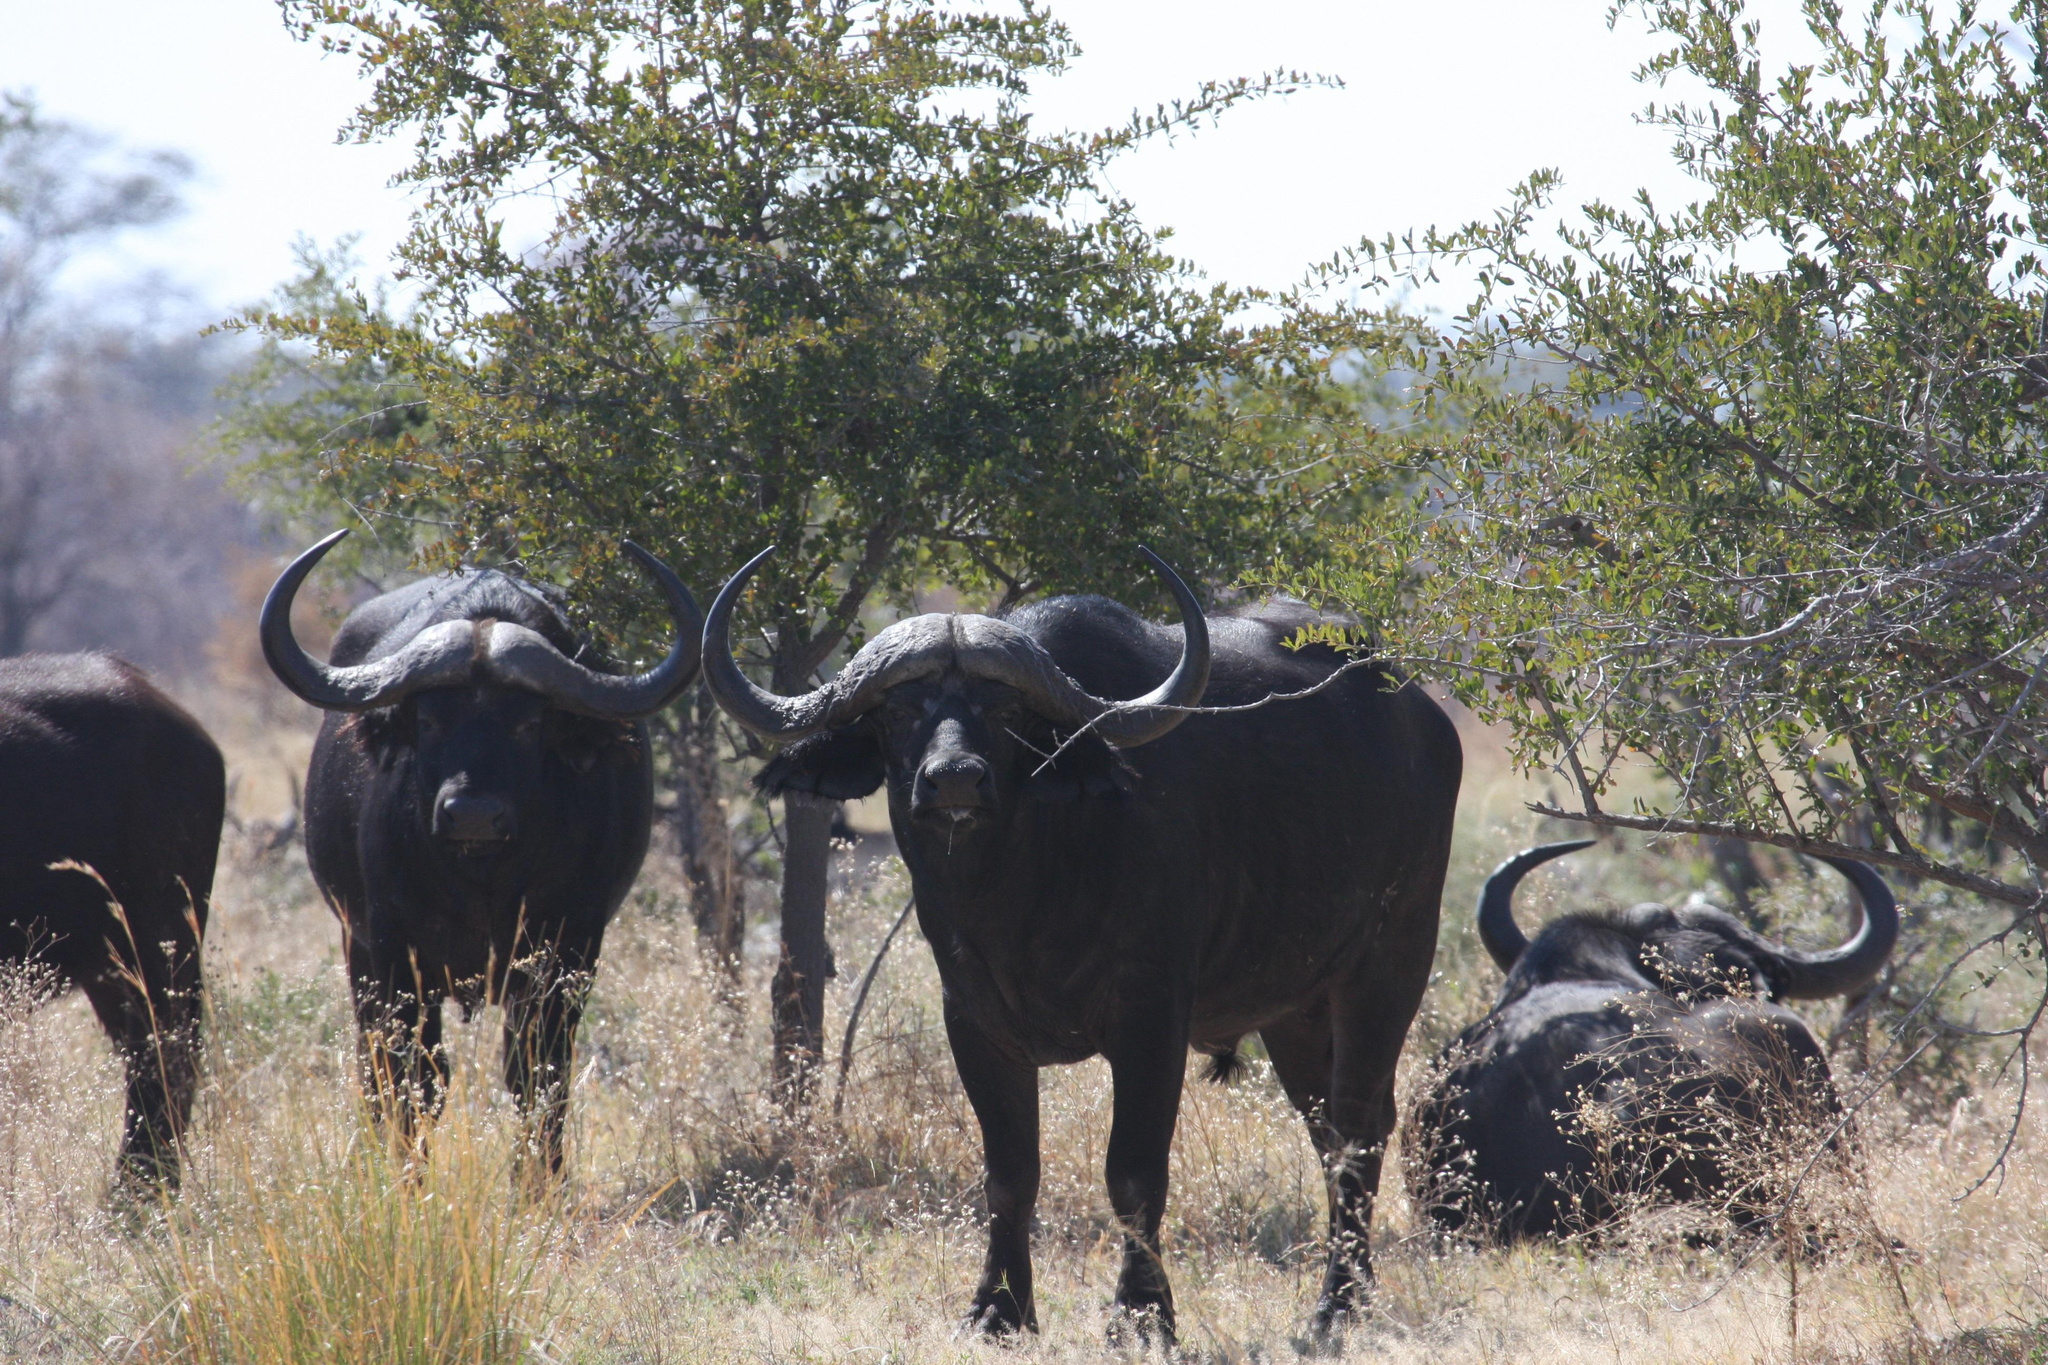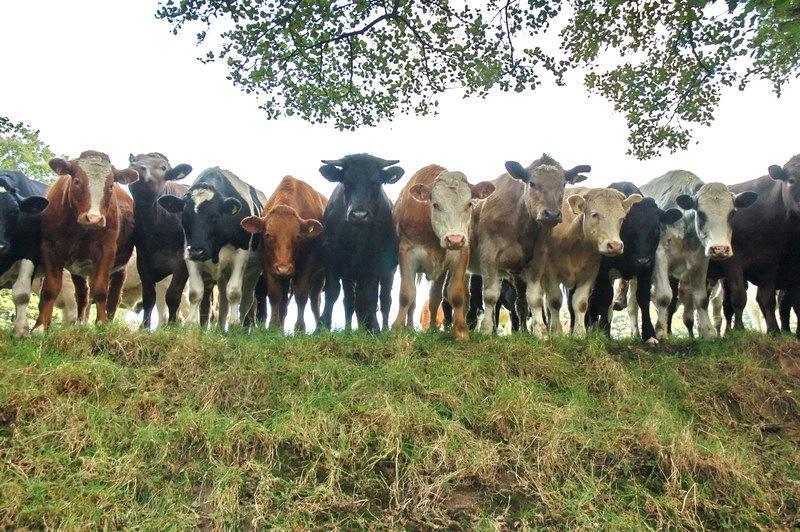The first image is the image on the left, the second image is the image on the right. Given the left and right images, does the statement "There are exactly three animals." hold true? Answer yes or no. No. 